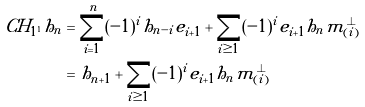Convert formula to latex. <formula><loc_0><loc_0><loc_500><loc_500>C H _ { 1 ^ { 1 } } h _ { n } & = \sum _ { i = 1 } ^ { n } ( - 1 ) ^ { i } h _ { n - i } e _ { i + 1 } + \sum _ { i \geq 1 } ( - 1 ) ^ { i } e _ { i + 1 } h _ { n } m _ { ( i ) } ^ { \perp } \\ & = h _ { n + 1 } + \sum _ { i \geq 1 } ( - 1 ) ^ { i } e _ { i + 1 } h _ { n } m _ { ( i ) } ^ { \perp }</formula> 